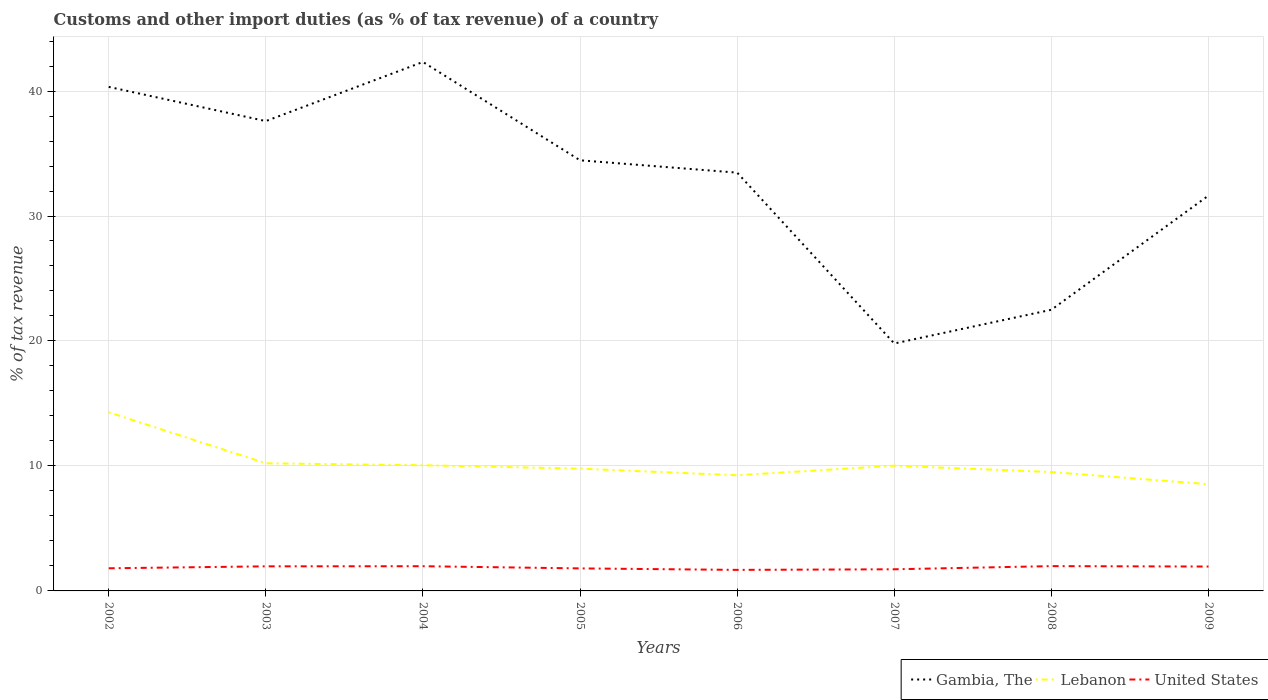Is the number of lines equal to the number of legend labels?
Keep it short and to the point. Yes. Across all years, what is the maximum percentage of tax revenue from customs in Lebanon?
Ensure brevity in your answer.  8.54. What is the total percentage of tax revenue from customs in Lebanon in the graph?
Make the answer very short. 0.19. What is the difference between the highest and the second highest percentage of tax revenue from customs in Lebanon?
Offer a very short reply. 5.75. What is the difference between the highest and the lowest percentage of tax revenue from customs in Gambia, The?
Ensure brevity in your answer.  5. Is the percentage of tax revenue from customs in Lebanon strictly greater than the percentage of tax revenue from customs in United States over the years?
Give a very brief answer. No. Are the values on the major ticks of Y-axis written in scientific E-notation?
Offer a terse response. No. Does the graph contain grids?
Ensure brevity in your answer.  Yes. Where does the legend appear in the graph?
Your answer should be compact. Bottom right. What is the title of the graph?
Your answer should be compact. Customs and other import duties (as % of tax revenue) of a country. Does "Macao" appear as one of the legend labels in the graph?
Your answer should be very brief. No. What is the label or title of the X-axis?
Offer a terse response. Years. What is the label or title of the Y-axis?
Give a very brief answer. % of tax revenue. What is the % of tax revenue in Gambia, The in 2002?
Give a very brief answer. 40.33. What is the % of tax revenue in Lebanon in 2002?
Provide a succinct answer. 14.3. What is the % of tax revenue of United States in 2002?
Make the answer very short. 1.81. What is the % of tax revenue in Gambia, The in 2003?
Offer a very short reply. 37.6. What is the % of tax revenue in Lebanon in 2003?
Keep it short and to the point. 10.21. What is the % of tax revenue in United States in 2003?
Keep it short and to the point. 1.97. What is the % of tax revenue of Gambia, The in 2004?
Make the answer very short. 42.33. What is the % of tax revenue in Lebanon in 2004?
Your answer should be compact. 10.06. What is the % of tax revenue in United States in 2004?
Offer a very short reply. 1.98. What is the % of tax revenue in Gambia, The in 2005?
Ensure brevity in your answer.  34.46. What is the % of tax revenue in Lebanon in 2005?
Make the answer very short. 9.78. What is the % of tax revenue in United States in 2005?
Make the answer very short. 1.8. What is the % of tax revenue in Gambia, The in 2006?
Your answer should be very brief. 33.47. What is the % of tax revenue of Lebanon in 2006?
Your answer should be very brief. 9.25. What is the % of tax revenue in United States in 2006?
Ensure brevity in your answer.  1.68. What is the % of tax revenue in Gambia, The in 2007?
Provide a succinct answer. 19.8. What is the % of tax revenue of Lebanon in 2007?
Keep it short and to the point. 10.02. What is the % of tax revenue of United States in 2007?
Offer a terse response. 1.73. What is the % of tax revenue of Gambia, The in 2008?
Your answer should be very brief. 22.5. What is the % of tax revenue of Lebanon in 2008?
Your answer should be very brief. 9.51. What is the % of tax revenue of United States in 2008?
Give a very brief answer. 1.98. What is the % of tax revenue of Gambia, The in 2009?
Provide a succinct answer. 31.64. What is the % of tax revenue of Lebanon in 2009?
Provide a short and direct response. 8.54. What is the % of tax revenue of United States in 2009?
Give a very brief answer. 1.95. Across all years, what is the maximum % of tax revenue of Gambia, The?
Offer a terse response. 42.33. Across all years, what is the maximum % of tax revenue of Lebanon?
Offer a terse response. 14.3. Across all years, what is the maximum % of tax revenue of United States?
Your answer should be very brief. 1.98. Across all years, what is the minimum % of tax revenue in Gambia, The?
Your answer should be very brief. 19.8. Across all years, what is the minimum % of tax revenue of Lebanon?
Offer a very short reply. 8.54. Across all years, what is the minimum % of tax revenue in United States?
Provide a succinct answer. 1.68. What is the total % of tax revenue of Gambia, The in the graph?
Offer a terse response. 262.11. What is the total % of tax revenue in Lebanon in the graph?
Keep it short and to the point. 81.68. What is the total % of tax revenue in United States in the graph?
Ensure brevity in your answer.  14.91. What is the difference between the % of tax revenue in Gambia, The in 2002 and that in 2003?
Make the answer very short. 2.74. What is the difference between the % of tax revenue in Lebanon in 2002 and that in 2003?
Your answer should be compact. 4.08. What is the difference between the % of tax revenue of United States in 2002 and that in 2003?
Provide a short and direct response. -0.16. What is the difference between the % of tax revenue in Gambia, The in 2002 and that in 2004?
Your response must be concise. -1.99. What is the difference between the % of tax revenue of Lebanon in 2002 and that in 2004?
Provide a short and direct response. 4.24. What is the difference between the % of tax revenue of United States in 2002 and that in 2004?
Make the answer very short. -0.17. What is the difference between the % of tax revenue in Gambia, The in 2002 and that in 2005?
Provide a short and direct response. 5.87. What is the difference between the % of tax revenue of Lebanon in 2002 and that in 2005?
Provide a short and direct response. 4.51. What is the difference between the % of tax revenue in United States in 2002 and that in 2005?
Your answer should be compact. 0.01. What is the difference between the % of tax revenue in Gambia, The in 2002 and that in 2006?
Your answer should be very brief. 6.86. What is the difference between the % of tax revenue of Lebanon in 2002 and that in 2006?
Your response must be concise. 5.04. What is the difference between the % of tax revenue of United States in 2002 and that in 2006?
Ensure brevity in your answer.  0.13. What is the difference between the % of tax revenue in Gambia, The in 2002 and that in 2007?
Make the answer very short. 20.53. What is the difference between the % of tax revenue of Lebanon in 2002 and that in 2007?
Ensure brevity in your answer.  4.27. What is the difference between the % of tax revenue in Gambia, The in 2002 and that in 2008?
Give a very brief answer. 17.83. What is the difference between the % of tax revenue of Lebanon in 2002 and that in 2008?
Your answer should be compact. 4.78. What is the difference between the % of tax revenue in United States in 2002 and that in 2008?
Make the answer very short. -0.17. What is the difference between the % of tax revenue of Gambia, The in 2002 and that in 2009?
Make the answer very short. 8.7. What is the difference between the % of tax revenue in Lebanon in 2002 and that in 2009?
Offer a very short reply. 5.75. What is the difference between the % of tax revenue in United States in 2002 and that in 2009?
Give a very brief answer. -0.14. What is the difference between the % of tax revenue in Gambia, The in 2003 and that in 2004?
Provide a short and direct response. -4.73. What is the difference between the % of tax revenue of Lebanon in 2003 and that in 2004?
Make the answer very short. 0.15. What is the difference between the % of tax revenue in United States in 2003 and that in 2004?
Provide a short and direct response. -0.01. What is the difference between the % of tax revenue of Gambia, The in 2003 and that in 2005?
Your answer should be very brief. 3.14. What is the difference between the % of tax revenue in Lebanon in 2003 and that in 2005?
Your response must be concise. 0.43. What is the difference between the % of tax revenue of United States in 2003 and that in 2005?
Keep it short and to the point. 0.17. What is the difference between the % of tax revenue in Gambia, The in 2003 and that in 2006?
Provide a short and direct response. 4.13. What is the difference between the % of tax revenue in Lebanon in 2003 and that in 2006?
Give a very brief answer. 0.96. What is the difference between the % of tax revenue of United States in 2003 and that in 2006?
Your response must be concise. 0.28. What is the difference between the % of tax revenue of Gambia, The in 2003 and that in 2007?
Your response must be concise. 17.8. What is the difference between the % of tax revenue of Lebanon in 2003 and that in 2007?
Your response must be concise. 0.19. What is the difference between the % of tax revenue in United States in 2003 and that in 2007?
Your answer should be very brief. 0.24. What is the difference between the % of tax revenue in Gambia, The in 2003 and that in 2008?
Keep it short and to the point. 15.1. What is the difference between the % of tax revenue in Lebanon in 2003 and that in 2008?
Provide a short and direct response. 0.7. What is the difference between the % of tax revenue in United States in 2003 and that in 2008?
Provide a short and direct response. -0.02. What is the difference between the % of tax revenue of Gambia, The in 2003 and that in 2009?
Keep it short and to the point. 5.96. What is the difference between the % of tax revenue in Lebanon in 2003 and that in 2009?
Your answer should be compact. 1.67. What is the difference between the % of tax revenue in United States in 2003 and that in 2009?
Provide a succinct answer. 0.02. What is the difference between the % of tax revenue in Gambia, The in 2004 and that in 2005?
Your answer should be compact. 7.87. What is the difference between the % of tax revenue of Lebanon in 2004 and that in 2005?
Make the answer very short. 0.27. What is the difference between the % of tax revenue of United States in 2004 and that in 2005?
Your answer should be very brief. 0.17. What is the difference between the % of tax revenue in Gambia, The in 2004 and that in 2006?
Provide a succinct answer. 8.86. What is the difference between the % of tax revenue in Lebanon in 2004 and that in 2006?
Your answer should be very brief. 0.8. What is the difference between the % of tax revenue of United States in 2004 and that in 2006?
Your response must be concise. 0.29. What is the difference between the % of tax revenue of Gambia, The in 2004 and that in 2007?
Your answer should be very brief. 22.53. What is the difference between the % of tax revenue of Lebanon in 2004 and that in 2007?
Your answer should be very brief. 0.04. What is the difference between the % of tax revenue of United States in 2004 and that in 2007?
Keep it short and to the point. 0.25. What is the difference between the % of tax revenue of Gambia, The in 2004 and that in 2008?
Offer a very short reply. 19.83. What is the difference between the % of tax revenue of Lebanon in 2004 and that in 2008?
Your answer should be very brief. 0.54. What is the difference between the % of tax revenue in United States in 2004 and that in 2008?
Offer a very short reply. -0.01. What is the difference between the % of tax revenue of Gambia, The in 2004 and that in 2009?
Your answer should be very brief. 10.69. What is the difference between the % of tax revenue of Lebanon in 2004 and that in 2009?
Make the answer very short. 1.52. What is the difference between the % of tax revenue in United States in 2004 and that in 2009?
Your response must be concise. 0.03. What is the difference between the % of tax revenue in Gambia, The in 2005 and that in 2006?
Keep it short and to the point. 0.99. What is the difference between the % of tax revenue of Lebanon in 2005 and that in 2006?
Offer a very short reply. 0.53. What is the difference between the % of tax revenue in United States in 2005 and that in 2006?
Give a very brief answer. 0.12. What is the difference between the % of tax revenue of Gambia, The in 2005 and that in 2007?
Offer a very short reply. 14.66. What is the difference between the % of tax revenue in Lebanon in 2005 and that in 2007?
Your answer should be very brief. -0.24. What is the difference between the % of tax revenue of United States in 2005 and that in 2007?
Give a very brief answer. 0.07. What is the difference between the % of tax revenue in Gambia, The in 2005 and that in 2008?
Offer a terse response. 11.96. What is the difference between the % of tax revenue in Lebanon in 2005 and that in 2008?
Provide a succinct answer. 0.27. What is the difference between the % of tax revenue of United States in 2005 and that in 2008?
Give a very brief answer. -0.18. What is the difference between the % of tax revenue in Gambia, The in 2005 and that in 2009?
Provide a succinct answer. 2.82. What is the difference between the % of tax revenue in Lebanon in 2005 and that in 2009?
Give a very brief answer. 1.24. What is the difference between the % of tax revenue in United States in 2005 and that in 2009?
Provide a short and direct response. -0.15. What is the difference between the % of tax revenue of Gambia, The in 2006 and that in 2007?
Offer a terse response. 13.67. What is the difference between the % of tax revenue of Lebanon in 2006 and that in 2007?
Provide a short and direct response. -0.77. What is the difference between the % of tax revenue of United States in 2006 and that in 2007?
Keep it short and to the point. -0.05. What is the difference between the % of tax revenue of Gambia, The in 2006 and that in 2008?
Make the answer very short. 10.97. What is the difference between the % of tax revenue in Lebanon in 2006 and that in 2008?
Make the answer very short. -0.26. What is the difference between the % of tax revenue in United States in 2006 and that in 2008?
Your response must be concise. -0.3. What is the difference between the % of tax revenue of Gambia, The in 2006 and that in 2009?
Keep it short and to the point. 1.83. What is the difference between the % of tax revenue of United States in 2006 and that in 2009?
Give a very brief answer. -0.27. What is the difference between the % of tax revenue of Gambia, The in 2007 and that in 2008?
Keep it short and to the point. -2.7. What is the difference between the % of tax revenue of Lebanon in 2007 and that in 2008?
Your response must be concise. 0.51. What is the difference between the % of tax revenue of United States in 2007 and that in 2008?
Ensure brevity in your answer.  -0.25. What is the difference between the % of tax revenue of Gambia, The in 2007 and that in 2009?
Your answer should be compact. -11.84. What is the difference between the % of tax revenue in Lebanon in 2007 and that in 2009?
Offer a very short reply. 1.48. What is the difference between the % of tax revenue in United States in 2007 and that in 2009?
Keep it short and to the point. -0.22. What is the difference between the % of tax revenue of Gambia, The in 2008 and that in 2009?
Your response must be concise. -9.14. What is the difference between the % of tax revenue in Lebanon in 2008 and that in 2009?
Your answer should be very brief. 0.97. What is the difference between the % of tax revenue of United States in 2008 and that in 2009?
Offer a terse response. 0.03. What is the difference between the % of tax revenue of Gambia, The in 2002 and the % of tax revenue of Lebanon in 2003?
Your response must be concise. 30.12. What is the difference between the % of tax revenue of Gambia, The in 2002 and the % of tax revenue of United States in 2003?
Provide a short and direct response. 38.36. What is the difference between the % of tax revenue in Lebanon in 2002 and the % of tax revenue in United States in 2003?
Keep it short and to the point. 12.33. What is the difference between the % of tax revenue of Gambia, The in 2002 and the % of tax revenue of Lebanon in 2004?
Your answer should be very brief. 30.27. What is the difference between the % of tax revenue of Gambia, The in 2002 and the % of tax revenue of United States in 2004?
Offer a terse response. 38.35. What is the difference between the % of tax revenue of Lebanon in 2002 and the % of tax revenue of United States in 2004?
Give a very brief answer. 12.32. What is the difference between the % of tax revenue of Gambia, The in 2002 and the % of tax revenue of Lebanon in 2005?
Ensure brevity in your answer.  30.55. What is the difference between the % of tax revenue of Gambia, The in 2002 and the % of tax revenue of United States in 2005?
Offer a terse response. 38.53. What is the difference between the % of tax revenue of Lebanon in 2002 and the % of tax revenue of United States in 2005?
Your answer should be compact. 12.49. What is the difference between the % of tax revenue of Gambia, The in 2002 and the % of tax revenue of Lebanon in 2006?
Your answer should be very brief. 31.08. What is the difference between the % of tax revenue of Gambia, The in 2002 and the % of tax revenue of United States in 2006?
Your answer should be very brief. 38.65. What is the difference between the % of tax revenue in Lebanon in 2002 and the % of tax revenue in United States in 2006?
Your answer should be compact. 12.61. What is the difference between the % of tax revenue in Gambia, The in 2002 and the % of tax revenue in Lebanon in 2007?
Your answer should be compact. 30.31. What is the difference between the % of tax revenue in Gambia, The in 2002 and the % of tax revenue in United States in 2007?
Offer a terse response. 38.6. What is the difference between the % of tax revenue of Lebanon in 2002 and the % of tax revenue of United States in 2007?
Make the answer very short. 12.56. What is the difference between the % of tax revenue in Gambia, The in 2002 and the % of tax revenue in Lebanon in 2008?
Provide a succinct answer. 30.82. What is the difference between the % of tax revenue in Gambia, The in 2002 and the % of tax revenue in United States in 2008?
Keep it short and to the point. 38.35. What is the difference between the % of tax revenue in Lebanon in 2002 and the % of tax revenue in United States in 2008?
Provide a succinct answer. 12.31. What is the difference between the % of tax revenue in Gambia, The in 2002 and the % of tax revenue in Lebanon in 2009?
Make the answer very short. 31.79. What is the difference between the % of tax revenue in Gambia, The in 2002 and the % of tax revenue in United States in 2009?
Keep it short and to the point. 38.38. What is the difference between the % of tax revenue in Lebanon in 2002 and the % of tax revenue in United States in 2009?
Offer a terse response. 12.34. What is the difference between the % of tax revenue in Gambia, The in 2003 and the % of tax revenue in Lebanon in 2004?
Ensure brevity in your answer.  27.54. What is the difference between the % of tax revenue in Gambia, The in 2003 and the % of tax revenue in United States in 2004?
Give a very brief answer. 35.62. What is the difference between the % of tax revenue of Lebanon in 2003 and the % of tax revenue of United States in 2004?
Provide a short and direct response. 8.24. What is the difference between the % of tax revenue of Gambia, The in 2003 and the % of tax revenue of Lebanon in 2005?
Offer a terse response. 27.81. What is the difference between the % of tax revenue of Gambia, The in 2003 and the % of tax revenue of United States in 2005?
Keep it short and to the point. 35.79. What is the difference between the % of tax revenue in Lebanon in 2003 and the % of tax revenue in United States in 2005?
Ensure brevity in your answer.  8.41. What is the difference between the % of tax revenue in Gambia, The in 2003 and the % of tax revenue in Lebanon in 2006?
Offer a very short reply. 28.34. What is the difference between the % of tax revenue in Gambia, The in 2003 and the % of tax revenue in United States in 2006?
Ensure brevity in your answer.  35.91. What is the difference between the % of tax revenue of Lebanon in 2003 and the % of tax revenue of United States in 2006?
Your answer should be compact. 8.53. What is the difference between the % of tax revenue of Gambia, The in 2003 and the % of tax revenue of Lebanon in 2007?
Ensure brevity in your answer.  27.57. What is the difference between the % of tax revenue in Gambia, The in 2003 and the % of tax revenue in United States in 2007?
Give a very brief answer. 35.86. What is the difference between the % of tax revenue in Lebanon in 2003 and the % of tax revenue in United States in 2007?
Ensure brevity in your answer.  8.48. What is the difference between the % of tax revenue in Gambia, The in 2003 and the % of tax revenue in Lebanon in 2008?
Offer a very short reply. 28.08. What is the difference between the % of tax revenue of Gambia, The in 2003 and the % of tax revenue of United States in 2008?
Provide a succinct answer. 35.61. What is the difference between the % of tax revenue in Lebanon in 2003 and the % of tax revenue in United States in 2008?
Offer a terse response. 8.23. What is the difference between the % of tax revenue of Gambia, The in 2003 and the % of tax revenue of Lebanon in 2009?
Your answer should be compact. 29.05. What is the difference between the % of tax revenue in Gambia, The in 2003 and the % of tax revenue in United States in 2009?
Your answer should be compact. 35.64. What is the difference between the % of tax revenue in Lebanon in 2003 and the % of tax revenue in United States in 2009?
Give a very brief answer. 8.26. What is the difference between the % of tax revenue in Gambia, The in 2004 and the % of tax revenue in Lebanon in 2005?
Your answer should be compact. 32.54. What is the difference between the % of tax revenue of Gambia, The in 2004 and the % of tax revenue of United States in 2005?
Keep it short and to the point. 40.52. What is the difference between the % of tax revenue of Lebanon in 2004 and the % of tax revenue of United States in 2005?
Give a very brief answer. 8.25. What is the difference between the % of tax revenue in Gambia, The in 2004 and the % of tax revenue in Lebanon in 2006?
Provide a succinct answer. 33.07. What is the difference between the % of tax revenue of Gambia, The in 2004 and the % of tax revenue of United States in 2006?
Your response must be concise. 40.64. What is the difference between the % of tax revenue of Lebanon in 2004 and the % of tax revenue of United States in 2006?
Give a very brief answer. 8.37. What is the difference between the % of tax revenue of Gambia, The in 2004 and the % of tax revenue of Lebanon in 2007?
Your answer should be very brief. 32.3. What is the difference between the % of tax revenue in Gambia, The in 2004 and the % of tax revenue in United States in 2007?
Your answer should be very brief. 40.59. What is the difference between the % of tax revenue of Lebanon in 2004 and the % of tax revenue of United States in 2007?
Provide a short and direct response. 8.33. What is the difference between the % of tax revenue in Gambia, The in 2004 and the % of tax revenue in Lebanon in 2008?
Provide a short and direct response. 32.81. What is the difference between the % of tax revenue of Gambia, The in 2004 and the % of tax revenue of United States in 2008?
Make the answer very short. 40.34. What is the difference between the % of tax revenue of Lebanon in 2004 and the % of tax revenue of United States in 2008?
Provide a short and direct response. 8.07. What is the difference between the % of tax revenue of Gambia, The in 2004 and the % of tax revenue of Lebanon in 2009?
Offer a very short reply. 33.78. What is the difference between the % of tax revenue of Gambia, The in 2004 and the % of tax revenue of United States in 2009?
Your response must be concise. 40.37. What is the difference between the % of tax revenue in Lebanon in 2004 and the % of tax revenue in United States in 2009?
Keep it short and to the point. 8.11. What is the difference between the % of tax revenue in Gambia, The in 2005 and the % of tax revenue in Lebanon in 2006?
Your response must be concise. 25.2. What is the difference between the % of tax revenue in Gambia, The in 2005 and the % of tax revenue in United States in 2006?
Provide a succinct answer. 32.77. What is the difference between the % of tax revenue in Lebanon in 2005 and the % of tax revenue in United States in 2006?
Your response must be concise. 8.1. What is the difference between the % of tax revenue of Gambia, The in 2005 and the % of tax revenue of Lebanon in 2007?
Your answer should be very brief. 24.44. What is the difference between the % of tax revenue of Gambia, The in 2005 and the % of tax revenue of United States in 2007?
Your answer should be very brief. 32.73. What is the difference between the % of tax revenue of Lebanon in 2005 and the % of tax revenue of United States in 2007?
Your response must be concise. 8.05. What is the difference between the % of tax revenue of Gambia, The in 2005 and the % of tax revenue of Lebanon in 2008?
Make the answer very short. 24.94. What is the difference between the % of tax revenue in Gambia, The in 2005 and the % of tax revenue in United States in 2008?
Your answer should be compact. 32.47. What is the difference between the % of tax revenue of Lebanon in 2005 and the % of tax revenue of United States in 2008?
Offer a terse response. 7.8. What is the difference between the % of tax revenue of Gambia, The in 2005 and the % of tax revenue of Lebanon in 2009?
Give a very brief answer. 25.92. What is the difference between the % of tax revenue in Gambia, The in 2005 and the % of tax revenue in United States in 2009?
Your answer should be compact. 32.51. What is the difference between the % of tax revenue in Lebanon in 2005 and the % of tax revenue in United States in 2009?
Your answer should be compact. 7.83. What is the difference between the % of tax revenue of Gambia, The in 2006 and the % of tax revenue of Lebanon in 2007?
Offer a very short reply. 23.45. What is the difference between the % of tax revenue of Gambia, The in 2006 and the % of tax revenue of United States in 2007?
Make the answer very short. 31.74. What is the difference between the % of tax revenue of Lebanon in 2006 and the % of tax revenue of United States in 2007?
Provide a short and direct response. 7.52. What is the difference between the % of tax revenue in Gambia, The in 2006 and the % of tax revenue in Lebanon in 2008?
Give a very brief answer. 23.96. What is the difference between the % of tax revenue in Gambia, The in 2006 and the % of tax revenue in United States in 2008?
Your answer should be compact. 31.48. What is the difference between the % of tax revenue in Lebanon in 2006 and the % of tax revenue in United States in 2008?
Offer a terse response. 7.27. What is the difference between the % of tax revenue in Gambia, The in 2006 and the % of tax revenue in Lebanon in 2009?
Your answer should be very brief. 24.93. What is the difference between the % of tax revenue of Gambia, The in 2006 and the % of tax revenue of United States in 2009?
Keep it short and to the point. 31.52. What is the difference between the % of tax revenue of Lebanon in 2006 and the % of tax revenue of United States in 2009?
Offer a terse response. 7.3. What is the difference between the % of tax revenue in Gambia, The in 2007 and the % of tax revenue in Lebanon in 2008?
Make the answer very short. 10.28. What is the difference between the % of tax revenue in Gambia, The in 2007 and the % of tax revenue in United States in 2008?
Offer a terse response. 17.81. What is the difference between the % of tax revenue of Lebanon in 2007 and the % of tax revenue of United States in 2008?
Offer a very short reply. 8.04. What is the difference between the % of tax revenue of Gambia, The in 2007 and the % of tax revenue of Lebanon in 2009?
Provide a succinct answer. 11.26. What is the difference between the % of tax revenue of Gambia, The in 2007 and the % of tax revenue of United States in 2009?
Make the answer very short. 17.85. What is the difference between the % of tax revenue of Lebanon in 2007 and the % of tax revenue of United States in 2009?
Make the answer very short. 8.07. What is the difference between the % of tax revenue of Gambia, The in 2008 and the % of tax revenue of Lebanon in 2009?
Your answer should be very brief. 13.96. What is the difference between the % of tax revenue of Gambia, The in 2008 and the % of tax revenue of United States in 2009?
Ensure brevity in your answer.  20.55. What is the difference between the % of tax revenue of Lebanon in 2008 and the % of tax revenue of United States in 2009?
Your answer should be very brief. 7.56. What is the average % of tax revenue of Gambia, The per year?
Your answer should be compact. 32.76. What is the average % of tax revenue of Lebanon per year?
Your answer should be compact. 10.21. What is the average % of tax revenue in United States per year?
Offer a terse response. 1.86. In the year 2002, what is the difference between the % of tax revenue of Gambia, The and % of tax revenue of Lebanon?
Make the answer very short. 26.04. In the year 2002, what is the difference between the % of tax revenue of Gambia, The and % of tax revenue of United States?
Your answer should be compact. 38.52. In the year 2002, what is the difference between the % of tax revenue of Lebanon and % of tax revenue of United States?
Ensure brevity in your answer.  12.48. In the year 2003, what is the difference between the % of tax revenue of Gambia, The and % of tax revenue of Lebanon?
Give a very brief answer. 27.38. In the year 2003, what is the difference between the % of tax revenue in Gambia, The and % of tax revenue in United States?
Your answer should be compact. 35.63. In the year 2003, what is the difference between the % of tax revenue of Lebanon and % of tax revenue of United States?
Your answer should be compact. 8.24. In the year 2004, what is the difference between the % of tax revenue in Gambia, The and % of tax revenue in Lebanon?
Give a very brief answer. 32.27. In the year 2004, what is the difference between the % of tax revenue in Gambia, The and % of tax revenue in United States?
Give a very brief answer. 40.35. In the year 2004, what is the difference between the % of tax revenue in Lebanon and % of tax revenue in United States?
Provide a succinct answer. 8.08. In the year 2005, what is the difference between the % of tax revenue in Gambia, The and % of tax revenue in Lebanon?
Ensure brevity in your answer.  24.67. In the year 2005, what is the difference between the % of tax revenue of Gambia, The and % of tax revenue of United States?
Your response must be concise. 32.66. In the year 2005, what is the difference between the % of tax revenue of Lebanon and % of tax revenue of United States?
Offer a terse response. 7.98. In the year 2006, what is the difference between the % of tax revenue in Gambia, The and % of tax revenue in Lebanon?
Make the answer very short. 24.21. In the year 2006, what is the difference between the % of tax revenue in Gambia, The and % of tax revenue in United States?
Give a very brief answer. 31.79. In the year 2006, what is the difference between the % of tax revenue of Lebanon and % of tax revenue of United States?
Give a very brief answer. 7.57. In the year 2007, what is the difference between the % of tax revenue of Gambia, The and % of tax revenue of Lebanon?
Your answer should be compact. 9.78. In the year 2007, what is the difference between the % of tax revenue in Gambia, The and % of tax revenue in United States?
Keep it short and to the point. 18.07. In the year 2007, what is the difference between the % of tax revenue of Lebanon and % of tax revenue of United States?
Your answer should be very brief. 8.29. In the year 2008, what is the difference between the % of tax revenue of Gambia, The and % of tax revenue of Lebanon?
Ensure brevity in your answer.  12.98. In the year 2008, what is the difference between the % of tax revenue of Gambia, The and % of tax revenue of United States?
Your answer should be compact. 20.51. In the year 2008, what is the difference between the % of tax revenue of Lebanon and % of tax revenue of United States?
Give a very brief answer. 7.53. In the year 2009, what is the difference between the % of tax revenue in Gambia, The and % of tax revenue in Lebanon?
Make the answer very short. 23.1. In the year 2009, what is the difference between the % of tax revenue in Gambia, The and % of tax revenue in United States?
Your answer should be compact. 29.69. In the year 2009, what is the difference between the % of tax revenue of Lebanon and % of tax revenue of United States?
Your answer should be compact. 6.59. What is the ratio of the % of tax revenue in Gambia, The in 2002 to that in 2003?
Ensure brevity in your answer.  1.07. What is the ratio of the % of tax revenue in Lebanon in 2002 to that in 2003?
Your answer should be very brief. 1.4. What is the ratio of the % of tax revenue in United States in 2002 to that in 2003?
Offer a terse response. 0.92. What is the ratio of the % of tax revenue of Gambia, The in 2002 to that in 2004?
Offer a terse response. 0.95. What is the ratio of the % of tax revenue in Lebanon in 2002 to that in 2004?
Keep it short and to the point. 1.42. What is the ratio of the % of tax revenue of United States in 2002 to that in 2004?
Give a very brief answer. 0.92. What is the ratio of the % of tax revenue in Gambia, The in 2002 to that in 2005?
Offer a terse response. 1.17. What is the ratio of the % of tax revenue in Lebanon in 2002 to that in 2005?
Ensure brevity in your answer.  1.46. What is the ratio of the % of tax revenue of United States in 2002 to that in 2005?
Offer a very short reply. 1. What is the ratio of the % of tax revenue of Gambia, The in 2002 to that in 2006?
Offer a terse response. 1.21. What is the ratio of the % of tax revenue in Lebanon in 2002 to that in 2006?
Your response must be concise. 1.54. What is the ratio of the % of tax revenue in United States in 2002 to that in 2006?
Provide a succinct answer. 1.08. What is the ratio of the % of tax revenue of Gambia, The in 2002 to that in 2007?
Offer a very short reply. 2.04. What is the ratio of the % of tax revenue in Lebanon in 2002 to that in 2007?
Keep it short and to the point. 1.43. What is the ratio of the % of tax revenue of United States in 2002 to that in 2007?
Keep it short and to the point. 1.05. What is the ratio of the % of tax revenue in Gambia, The in 2002 to that in 2008?
Your response must be concise. 1.79. What is the ratio of the % of tax revenue in Lebanon in 2002 to that in 2008?
Provide a short and direct response. 1.5. What is the ratio of the % of tax revenue in United States in 2002 to that in 2008?
Your answer should be compact. 0.91. What is the ratio of the % of tax revenue of Gambia, The in 2002 to that in 2009?
Give a very brief answer. 1.27. What is the ratio of the % of tax revenue in Lebanon in 2002 to that in 2009?
Provide a short and direct response. 1.67. What is the ratio of the % of tax revenue in United States in 2002 to that in 2009?
Your answer should be compact. 0.93. What is the ratio of the % of tax revenue of Gambia, The in 2003 to that in 2004?
Provide a short and direct response. 0.89. What is the ratio of the % of tax revenue of Lebanon in 2003 to that in 2004?
Provide a succinct answer. 1.02. What is the ratio of the % of tax revenue in Gambia, The in 2003 to that in 2005?
Your answer should be very brief. 1.09. What is the ratio of the % of tax revenue in Lebanon in 2003 to that in 2005?
Provide a short and direct response. 1.04. What is the ratio of the % of tax revenue in United States in 2003 to that in 2005?
Give a very brief answer. 1.09. What is the ratio of the % of tax revenue in Gambia, The in 2003 to that in 2006?
Provide a short and direct response. 1.12. What is the ratio of the % of tax revenue in Lebanon in 2003 to that in 2006?
Provide a succinct answer. 1.1. What is the ratio of the % of tax revenue of United States in 2003 to that in 2006?
Ensure brevity in your answer.  1.17. What is the ratio of the % of tax revenue of Gambia, The in 2003 to that in 2007?
Keep it short and to the point. 1.9. What is the ratio of the % of tax revenue in United States in 2003 to that in 2007?
Provide a succinct answer. 1.14. What is the ratio of the % of tax revenue of Gambia, The in 2003 to that in 2008?
Give a very brief answer. 1.67. What is the ratio of the % of tax revenue of Lebanon in 2003 to that in 2008?
Your answer should be very brief. 1.07. What is the ratio of the % of tax revenue in Gambia, The in 2003 to that in 2009?
Give a very brief answer. 1.19. What is the ratio of the % of tax revenue of Lebanon in 2003 to that in 2009?
Make the answer very short. 1.2. What is the ratio of the % of tax revenue of United States in 2003 to that in 2009?
Provide a short and direct response. 1.01. What is the ratio of the % of tax revenue of Gambia, The in 2004 to that in 2005?
Provide a short and direct response. 1.23. What is the ratio of the % of tax revenue in Lebanon in 2004 to that in 2005?
Your answer should be compact. 1.03. What is the ratio of the % of tax revenue in United States in 2004 to that in 2005?
Give a very brief answer. 1.1. What is the ratio of the % of tax revenue in Gambia, The in 2004 to that in 2006?
Offer a very short reply. 1.26. What is the ratio of the % of tax revenue in Lebanon in 2004 to that in 2006?
Your answer should be very brief. 1.09. What is the ratio of the % of tax revenue of United States in 2004 to that in 2006?
Make the answer very short. 1.17. What is the ratio of the % of tax revenue in Gambia, The in 2004 to that in 2007?
Make the answer very short. 2.14. What is the ratio of the % of tax revenue of United States in 2004 to that in 2007?
Make the answer very short. 1.14. What is the ratio of the % of tax revenue in Gambia, The in 2004 to that in 2008?
Offer a terse response. 1.88. What is the ratio of the % of tax revenue in Lebanon in 2004 to that in 2008?
Give a very brief answer. 1.06. What is the ratio of the % of tax revenue of Gambia, The in 2004 to that in 2009?
Provide a succinct answer. 1.34. What is the ratio of the % of tax revenue of Lebanon in 2004 to that in 2009?
Your response must be concise. 1.18. What is the ratio of the % of tax revenue in United States in 2004 to that in 2009?
Make the answer very short. 1.01. What is the ratio of the % of tax revenue of Gambia, The in 2005 to that in 2006?
Your answer should be compact. 1.03. What is the ratio of the % of tax revenue in Lebanon in 2005 to that in 2006?
Keep it short and to the point. 1.06. What is the ratio of the % of tax revenue of United States in 2005 to that in 2006?
Ensure brevity in your answer.  1.07. What is the ratio of the % of tax revenue in Gambia, The in 2005 to that in 2007?
Your answer should be very brief. 1.74. What is the ratio of the % of tax revenue of Lebanon in 2005 to that in 2007?
Ensure brevity in your answer.  0.98. What is the ratio of the % of tax revenue in United States in 2005 to that in 2007?
Provide a succinct answer. 1.04. What is the ratio of the % of tax revenue in Gambia, The in 2005 to that in 2008?
Make the answer very short. 1.53. What is the ratio of the % of tax revenue of Lebanon in 2005 to that in 2008?
Provide a short and direct response. 1.03. What is the ratio of the % of tax revenue of United States in 2005 to that in 2008?
Give a very brief answer. 0.91. What is the ratio of the % of tax revenue in Gambia, The in 2005 to that in 2009?
Make the answer very short. 1.09. What is the ratio of the % of tax revenue of Lebanon in 2005 to that in 2009?
Offer a terse response. 1.15. What is the ratio of the % of tax revenue in United States in 2005 to that in 2009?
Offer a terse response. 0.92. What is the ratio of the % of tax revenue in Gambia, The in 2006 to that in 2007?
Your answer should be very brief. 1.69. What is the ratio of the % of tax revenue of Lebanon in 2006 to that in 2007?
Your response must be concise. 0.92. What is the ratio of the % of tax revenue of United States in 2006 to that in 2007?
Make the answer very short. 0.97. What is the ratio of the % of tax revenue in Gambia, The in 2006 to that in 2008?
Your answer should be compact. 1.49. What is the ratio of the % of tax revenue in Lebanon in 2006 to that in 2008?
Your response must be concise. 0.97. What is the ratio of the % of tax revenue of United States in 2006 to that in 2008?
Make the answer very short. 0.85. What is the ratio of the % of tax revenue in Gambia, The in 2006 to that in 2009?
Give a very brief answer. 1.06. What is the ratio of the % of tax revenue of Lebanon in 2006 to that in 2009?
Your answer should be very brief. 1.08. What is the ratio of the % of tax revenue in United States in 2006 to that in 2009?
Your response must be concise. 0.86. What is the ratio of the % of tax revenue in Lebanon in 2007 to that in 2008?
Keep it short and to the point. 1.05. What is the ratio of the % of tax revenue of United States in 2007 to that in 2008?
Provide a succinct answer. 0.87. What is the ratio of the % of tax revenue of Gambia, The in 2007 to that in 2009?
Your answer should be very brief. 0.63. What is the ratio of the % of tax revenue in Lebanon in 2007 to that in 2009?
Provide a succinct answer. 1.17. What is the ratio of the % of tax revenue in United States in 2007 to that in 2009?
Your response must be concise. 0.89. What is the ratio of the % of tax revenue of Gambia, The in 2008 to that in 2009?
Keep it short and to the point. 0.71. What is the ratio of the % of tax revenue in Lebanon in 2008 to that in 2009?
Your answer should be very brief. 1.11. What is the ratio of the % of tax revenue in United States in 2008 to that in 2009?
Ensure brevity in your answer.  1.02. What is the difference between the highest and the second highest % of tax revenue of Gambia, The?
Your response must be concise. 1.99. What is the difference between the highest and the second highest % of tax revenue of Lebanon?
Provide a succinct answer. 4.08. What is the difference between the highest and the second highest % of tax revenue of United States?
Give a very brief answer. 0.01. What is the difference between the highest and the lowest % of tax revenue of Gambia, The?
Your answer should be very brief. 22.53. What is the difference between the highest and the lowest % of tax revenue in Lebanon?
Keep it short and to the point. 5.75. What is the difference between the highest and the lowest % of tax revenue of United States?
Provide a succinct answer. 0.3. 